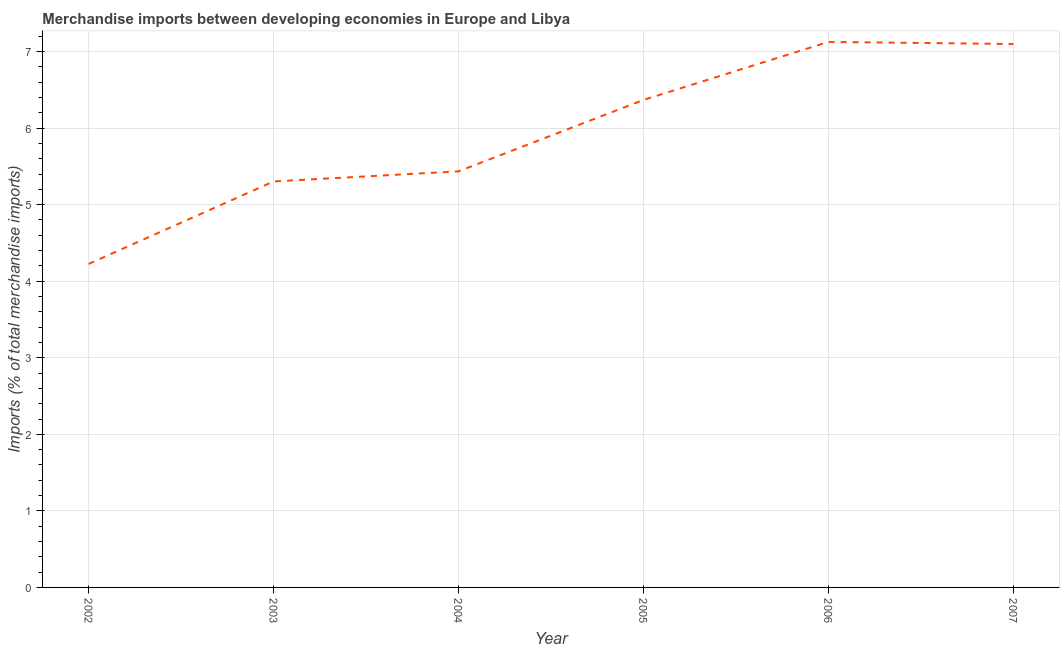What is the merchandise imports in 2002?
Offer a very short reply. 4.23. Across all years, what is the maximum merchandise imports?
Your response must be concise. 7.13. Across all years, what is the minimum merchandise imports?
Your answer should be very brief. 4.23. In which year was the merchandise imports maximum?
Ensure brevity in your answer.  2006. In which year was the merchandise imports minimum?
Ensure brevity in your answer.  2002. What is the sum of the merchandise imports?
Your response must be concise. 35.56. What is the difference between the merchandise imports in 2002 and 2007?
Your response must be concise. -2.87. What is the average merchandise imports per year?
Your answer should be very brief. 5.93. What is the median merchandise imports?
Your answer should be compact. 5.9. In how many years, is the merchandise imports greater than 0.2 %?
Offer a very short reply. 6. What is the ratio of the merchandise imports in 2002 to that in 2003?
Your answer should be compact. 0.8. Is the merchandise imports in 2006 less than that in 2007?
Keep it short and to the point. No. What is the difference between the highest and the second highest merchandise imports?
Offer a terse response. 0.03. What is the difference between the highest and the lowest merchandise imports?
Make the answer very short. 2.9. In how many years, is the merchandise imports greater than the average merchandise imports taken over all years?
Provide a succinct answer. 3. Does the merchandise imports monotonically increase over the years?
Keep it short and to the point. No. How many lines are there?
Your answer should be compact. 1. How many years are there in the graph?
Ensure brevity in your answer.  6. What is the difference between two consecutive major ticks on the Y-axis?
Keep it short and to the point. 1. What is the title of the graph?
Offer a terse response. Merchandise imports between developing economies in Europe and Libya. What is the label or title of the Y-axis?
Provide a succinct answer. Imports (% of total merchandise imports). What is the Imports (% of total merchandise imports) of 2002?
Keep it short and to the point. 4.23. What is the Imports (% of total merchandise imports) in 2003?
Your answer should be very brief. 5.3. What is the Imports (% of total merchandise imports) of 2004?
Offer a very short reply. 5.44. What is the Imports (% of total merchandise imports) of 2005?
Offer a terse response. 6.37. What is the Imports (% of total merchandise imports) in 2006?
Provide a succinct answer. 7.13. What is the Imports (% of total merchandise imports) in 2007?
Ensure brevity in your answer.  7.1. What is the difference between the Imports (% of total merchandise imports) in 2002 and 2003?
Provide a short and direct response. -1.08. What is the difference between the Imports (% of total merchandise imports) in 2002 and 2004?
Give a very brief answer. -1.21. What is the difference between the Imports (% of total merchandise imports) in 2002 and 2005?
Keep it short and to the point. -2.14. What is the difference between the Imports (% of total merchandise imports) in 2002 and 2006?
Ensure brevity in your answer.  -2.9. What is the difference between the Imports (% of total merchandise imports) in 2002 and 2007?
Provide a short and direct response. -2.87. What is the difference between the Imports (% of total merchandise imports) in 2003 and 2004?
Make the answer very short. -0.13. What is the difference between the Imports (% of total merchandise imports) in 2003 and 2005?
Provide a short and direct response. -1.06. What is the difference between the Imports (% of total merchandise imports) in 2003 and 2006?
Offer a very short reply. -1.82. What is the difference between the Imports (% of total merchandise imports) in 2003 and 2007?
Ensure brevity in your answer.  -1.8. What is the difference between the Imports (% of total merchandise imports) in 2004 and 2005?
Provide a succinct answer. -0.93. What is the difference between the Imports (% of total merchandise imports) in 2004 and 2006?
Offer a very short reply. -1.69. What is the difference between the Imports (% of total merchandise imports) in 2004 and 2007?
Provide a short and direct response. -1.66. What is the difference between the Imports (% of total merchandise imports) in 2005 and 2006?
Your response must be concise. -0.76. What is the difference between the Imports (% of total merchandise imports) in 2005 and 2007?
Keep it short and to the point. -0.73. What is the difference between the Imports (% of total merchandise imports) in 2006 and 2007?
Ensure brevity in your answer.  0.03. What is the ratio of the Imports (% of total merchandise imports) in 2002 to that in 2003?
Ensure brevity in your answer.  0.8. What is the ratio of the Imports (% of total merchandise imports) in 2002 to that in 2004?
Provide a short and direct response. 0.78. What is the ratio of the Imports (% of total merchandise imports) in 2002 to that in 2005?
Your answer should be very brief. 0.66. What is the ratio of the Imports (% of total merchandise imports) in 2002 to that in 2006?
Your answer should be compact. 0.59. What is the ratio of the Imports (% of total merchandise imports) in 2002 to that in 2007?
Your answer should be compact. 0.59. What is the ratio of the Imports (% of total merchandise imports) in 2003 to that in 2004?
Offer a very short reply. 0.98. What is the ratio of the Imports (% of total merchandise imports) in 2003 to that in 2005?
Make the answer very short. 0.83. What is the ratio of the Imports (% of total merchandise imports) in 2003 to that in 2006?
Keep it short and to the point. 0.74. What is the ratio of the Imports (% of total merchandise imports) in 2003 to that in 2007?
Keep it short and to the point. 0.75. What is the ratio of the Imports (% of total merchandise imports) in 2004 to that in 2005?
Provide a short and direct response. 0.85. What is the ratio of the Imports (% of total merchandise imports) in 2004 to that in 2006?
Offer a terse response. 0.76. What is the ratio of the Imports (% of total merchandise imports) in 2004 to that in 2007?
Your response must be concise. 0.77. What is the ratio of the Imports (% of total merchandise imports) in 2005 to that in 2006?
Ensure brevity in your answer.  0.89. What is the ratio of the Imports (% of total merchandise imports) in 2005 to that in 2007?
Offer a terse response. 0.9. What is the ratio of the Imports (% of total merchandise imports) in 2006 to that in 2007?
Make the answer very short. 1. 